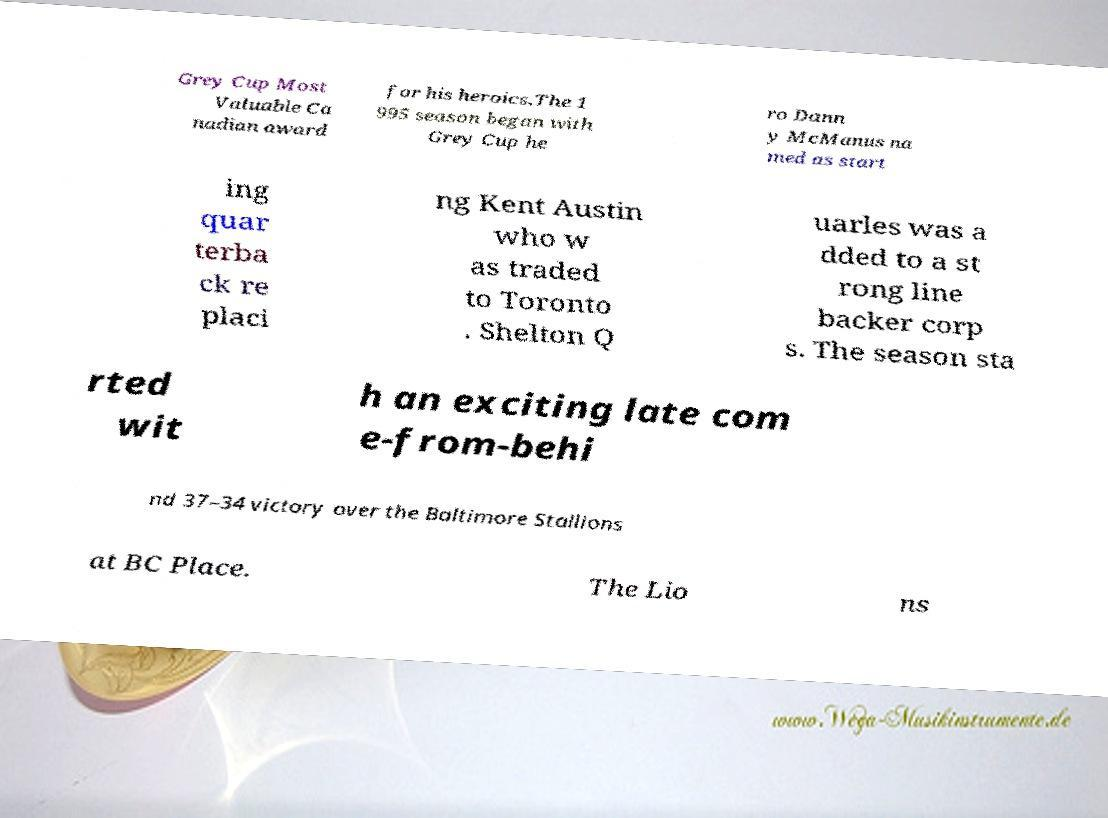Could you assist in decoding the text presented in this image and type it out clearly? Grey Cup Most Valuable Ca nadian award for his heroics.The 1 995 season began with Grey Cup he ro Dann y McManus na med as start ing quar terba ck re placi ng Kent Austin who w as traded to Toronto . Shelton Q uarles was a dded to a st rong line backer corp s. The season sta rted wit h an exciting late com e-from-behi nd 37–34 victory over the Baltimore Stallions at BC Place. The Lio ns 